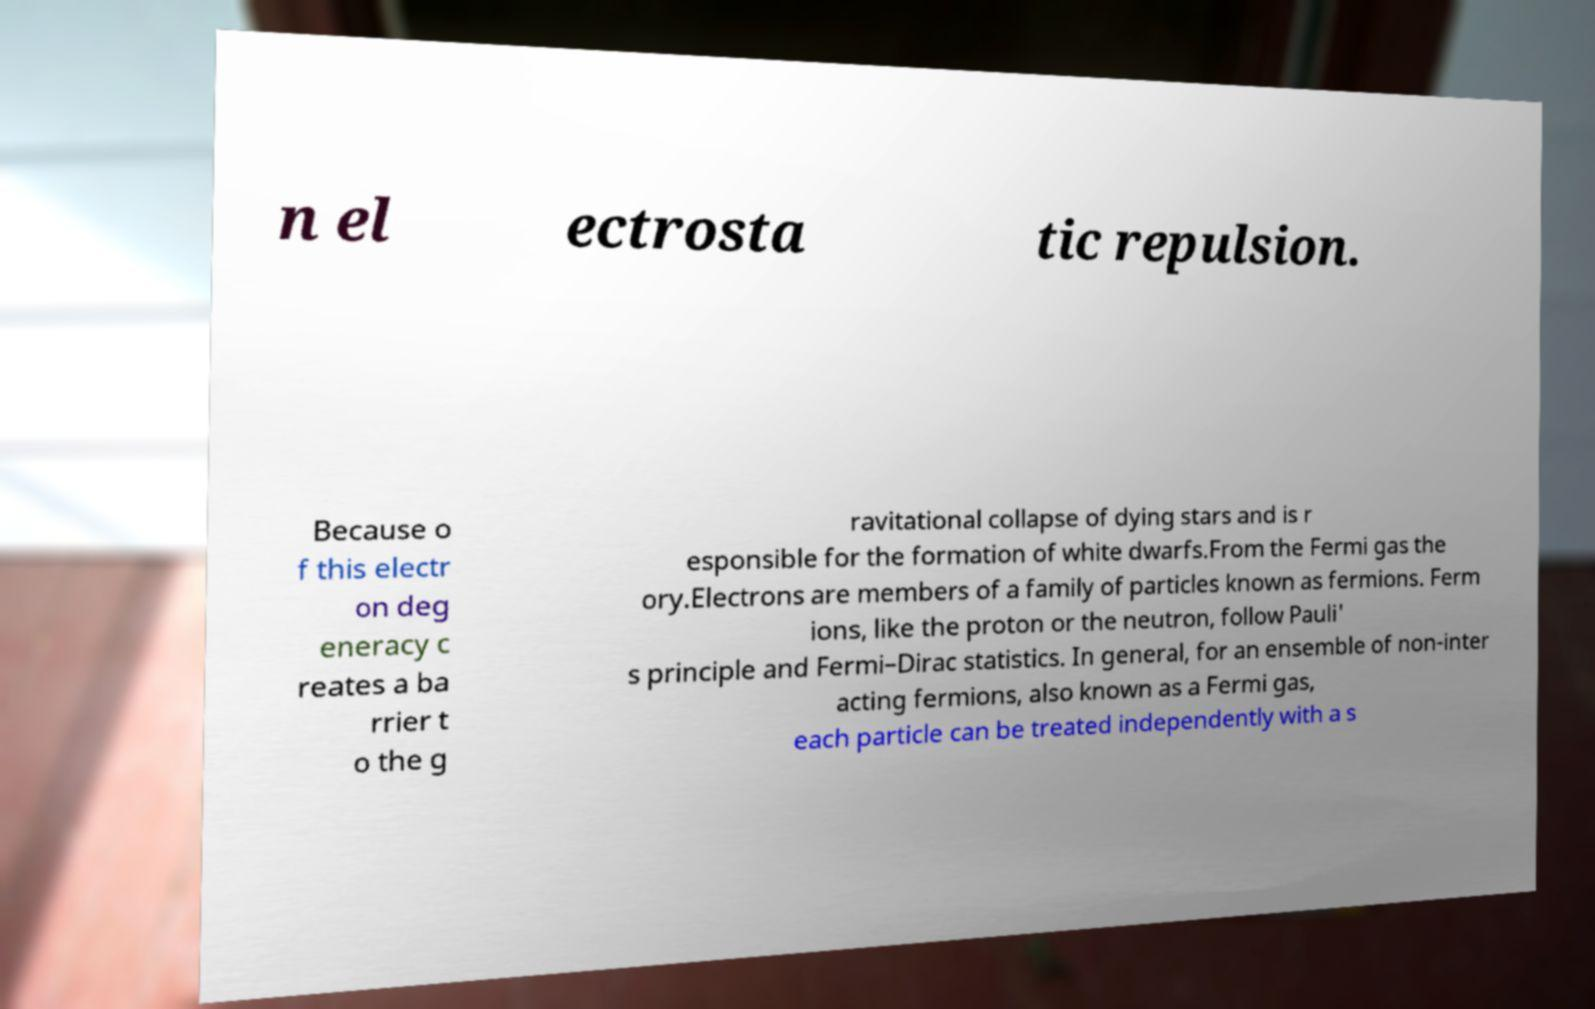Could you extract and type out the text from this image? n el ectrosta tic repulsion. Because o f this electr on deg eneracy c reates a ba rrier t o the g ravitational collapse of dying stars and is r esponsible for the formation of white dwarfs.From the Fermi gas the ory.Electrons are members of a family of particles known as fermions. Ferm ions, like the proton or the neutron, follow Pauli' s principle and Fermi–Dirac statistics. In general, for an ensemble of non-inter acting fermions, also known as a Fermi gas, each particle can be treated independently with a s 